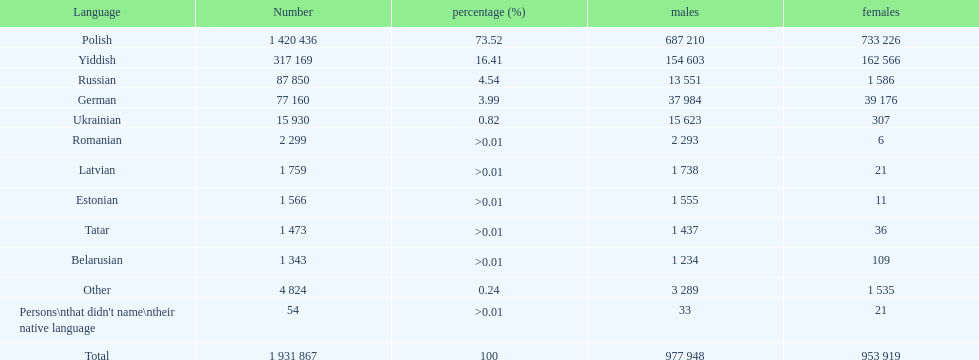What's the population of russian-speaking men? 13 551. 